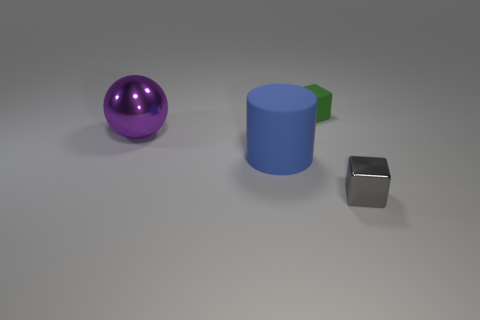Add 4 big purple matte things. How many objects exist? 8 Subtract all balls. How many objects are left? 3 Add 4 gray blocks. How many gray blocks exist? 5 Subtract 0 red cubes. How many objects are left? 4 Subtract all gray shiny blocks. Subtract all big spheres. How many objects are left? 2 Add 1 gray metal objects. How many gray metal objects are left? 2 